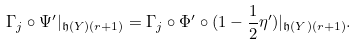<formula> <loc_0><loc_0><loc_500><loc_500>\Gamma _ { j } \circ \Psi ^ { \prime } | _ { \mathfrak { h } ( Y ) ( r + 1 ) } = \Gamma _ { j } \circ \Phi ^ { \prime } \circ ( 1 - \frac { 1 } { 2 } \eta ^ { \prime } ) | _ { \mathfrak { h } ( Y ) ( r + 1 ) } .</formula> 